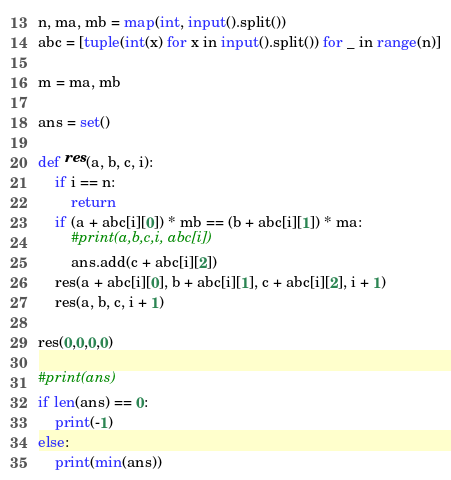<code> <loc_0><loc_0><loc_500><loc_500><_Python_>n, ma, mb = map(int, input().split())
abc = [tuple(int(x) for x in input().split()) for _ in range(n)]

m = ma, mb

ans = set()

def res(a, b, c, i):
    if i == n:
        return
    if (a + abc[i][0]) * mb == (b + abc[i][1]) * ma:
        #print(a,b,c,i, abc[i])
        ans.add(c + abc[i][2])
    res(a + abc[i][0], b + abc[i][1], c + abc[i][2], i + 1)
    res(a, b, c, i + 1)

res(0,0,0,0)

#print(ans)
if len(ans) == 0:
    print(-1)
else:
    print(min(ans))</code> 